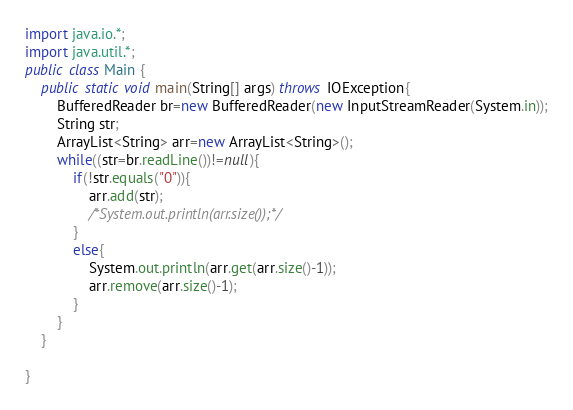Convert code to text. <code><loc_0><loc_0><loc_500><loc_500><_Java_>import java.io.*;
import java.util.*;
public class Main {
	public static void main(String[] args) throws IOException{
		BufferedReader br=new BufferedReader(new InputStreamReader(System.in));
		String str;
		ArrayList<String> arr=new ArrayList<String>();
		while((str=br.readLine())!=null){
			if(!str.equals("0")){
				arr.add(str);
				/*System.out.println(arr.size());*/
			}
			else{
				System.out.println(arr.get(arr.size()-1));
				arr.remove(arr.size()-1);
			}
		}
	}

}</code> 